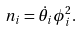Convert formula to latex. <formula><loc_0><loc_0><loc_500><loc_500>n _ { i } = { \dot { \theta } _ { i } } \phi ^ { 2 } _ { i } .</formula> 